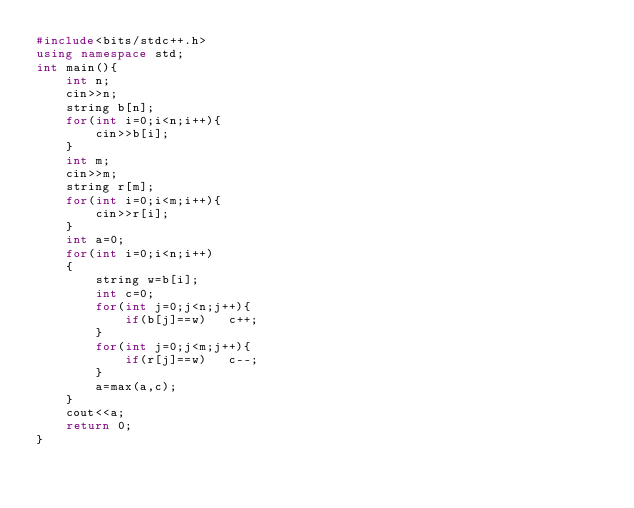<code> <loc_0><loc_0><loc_500><loc_500><_C++_>#include<bits/stdc++.h>
using namespace std;
int main(){
	int n;
	cin>>n;
	string b[n];
	for(int i=0;i<n;i++){
		cin>>b[i];
	}
	int m;
	cin>>m;
	string r[m];
	for(int i=0;i<m;i++){
		cin>>r[i];
	}
	int a=0;
	for(int i=0;i<n;i++)
	{
	    string w=b[i];
	    int c=0;
	    for(int j=0;j<n;j++){
	    	if(b[j]==w)   c++;
	    }
	    for(int j=0;j<m;j++){
	    	if(r[j]==w)   c--;
	    }
	    a=max(a,c);
	}
	cout<<a;
	return 0;
}</code> 